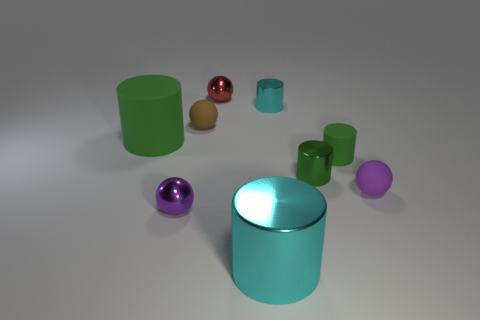Can you guess what material the spheres might be made of? The spheres have a glossy finish, suggesting they could be made of a polished material like metal or possibly plastic with a reflective coating. 